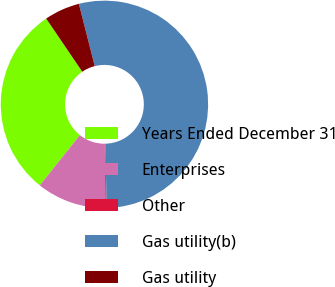Convert chart to OTSL. <chart><loc_0><loc_0><loc_500><loc_500><pie_chart><fcel>Years Ended December 31<fcel>Enterprises<fcel>Other<fcel>Gas utility(b)<fcel>Gas utility<nl><fcel>29.78%<fcel>10.88%<fcel>0.19%<fcel>53.61%<fcel>5.53%<nl></chart> 